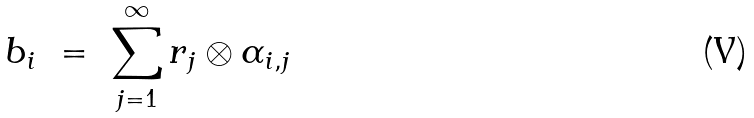Convert formula to latex. <formula><loc_0><loc_0><loc_500><loc_500>b _ { i } \ = \ \sum _ { j = 1 } ^ { \infty } r _ { j } \otimes \alpha _ { i , j }</formula> 